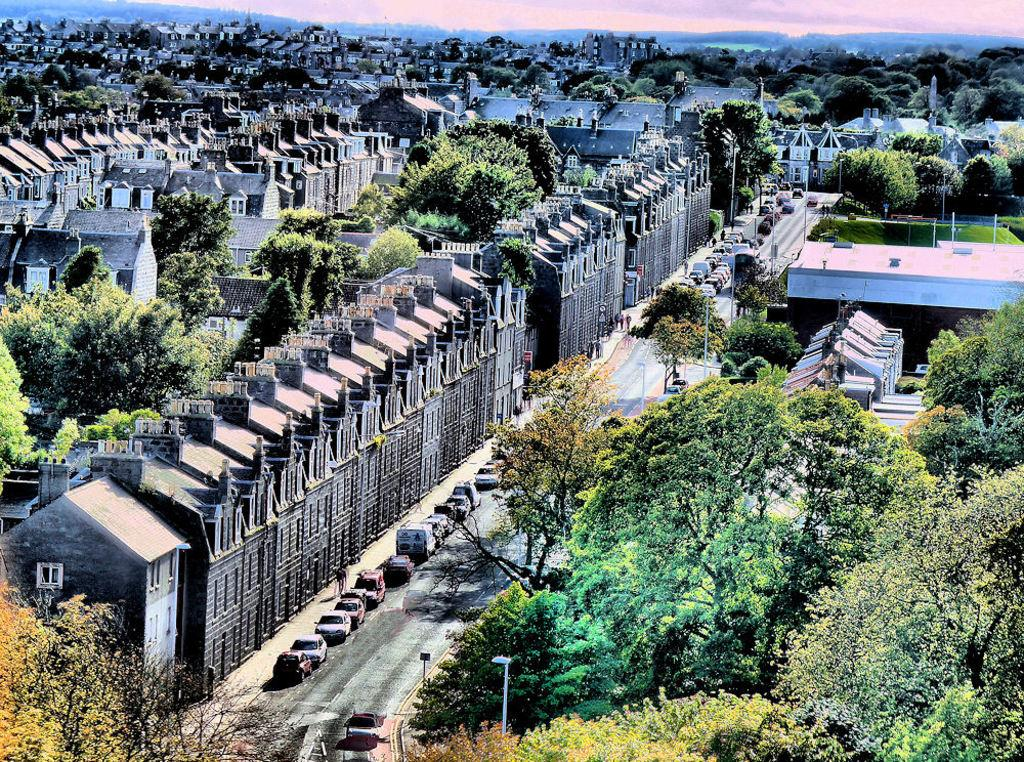What type of structures can be seen in the image? There are buildings in the image. What other natural elements are present in the image? There are trees and mountains visible in the image. What man-made objects can be seen in the image? There are poles and vehicles on the road in the image. What is visible in the background of the image? Mountains are visible in the background of the image. What is visible in the sky in the image? The sky is visible in the image, and there are clouds present. Can you tell me who is winning the argument in the image? There is no argument present in the image; it features buildings, trees, poles, vehicles, mountains, and clouds. What type of porter is carrying the mountains in the image? There is no porter present in the image, and the mountains are not being carried; they are part of the background landscape. 